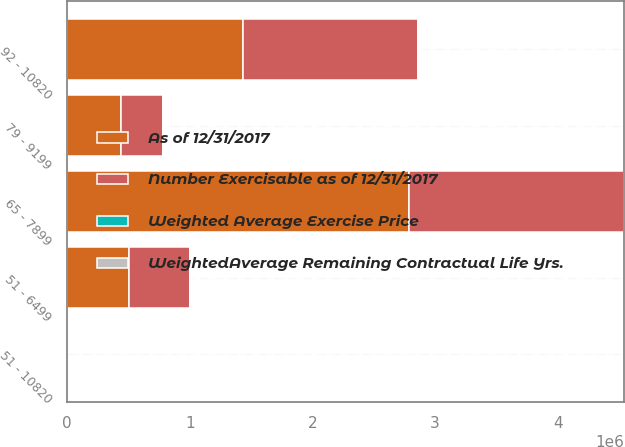<chart> <loc_0><loc_0><loc_500><loc_500><stacked_bar_chart><ecel><fcel>51 - 6499<fcel>65 - 7899<fcel>79 - 9199<fcel>92 - 10820<fcel>51 - 10820<nl><fcel>As of 12/31/2017<fcel>502709<fcel>2.79004e+06<fcel>441000<fcel>1.4311e+06<fcel>99.05<nl><fcel>WeightedAverage Remaining Contractual Life Yrs.<fcel>5.73<fcel>5.56<fcel>7.08<fcel>0.06<fcel>4.18<nl><fcel>Weighted Average Exercise Price<fcel>63.68<fcel>72.94<fcel>89.9<fcel>108.2<fcel>83.26<nl><fcel>Number Exercisable as of 12/31/2017<fcel>502709<fcel>1.7514e+06<fcel>342691<fcel>1.4311e+06<fcel>99.05<nl></chart> 